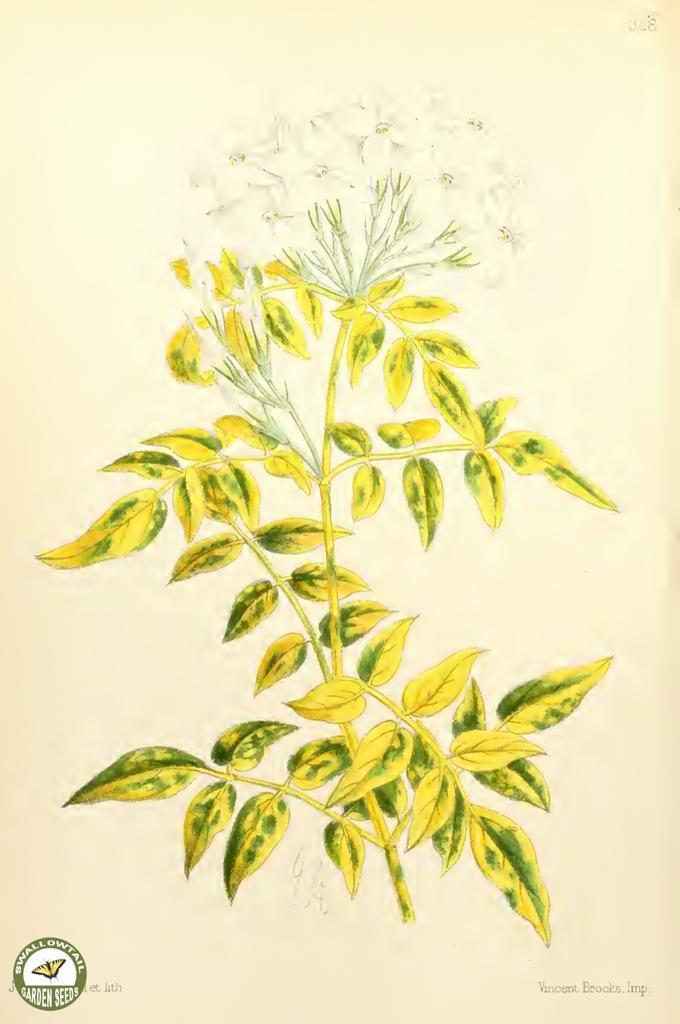How would you summarize this image in a sentence or two? In this image we can see a poster on which we can see a plant and we can also see a logo on the left side at the bottom. 